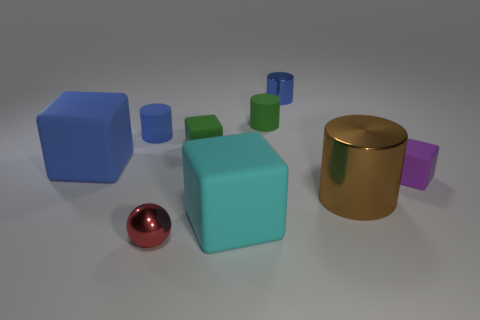Add 1 large blue things. How many objects exist? 10 Subtract all cubes. How many objects are left? 5 Add 6 large matte things. How many large matte things are left? 8 Add 5 matte cylinders. How many matte cylinders exist? 7 Subtract 0 cyan cylinders. How many objects are left? 9 Subtract all large brown objects. Subtract all red metallic spheres. How many objects are left? 7 